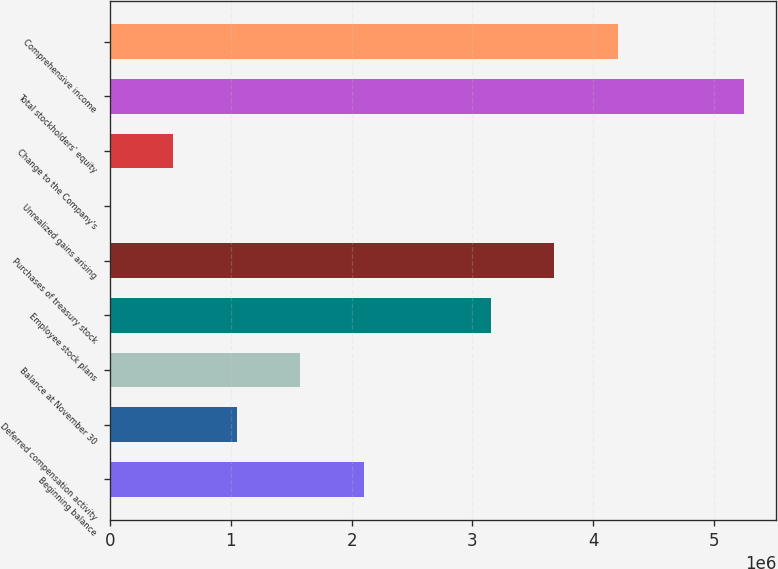Convert chart. <chart><loc_0><loc_0><loc_500><loc_500><bar_chart><fcel>Beginning balance<fcel>Deferred compensation activity<fcel>Balance at November 30<fcel>Employee stock plans<fcel>Purchases of treasury stock<fcel>Unrealized gains arising<fcel>Change to the Company's<fcel>Total stockholders' equity<fcel>Comprehensive income<nl><fcel>2.10068e+06<fcel>1.05043e+06<fcel>1.57555e+06<fcel>3.15092e+06<fcel>3.67604e+06<fcel>185<fcel>525308<fcel>5.25141e+06<fcel>4.20117e+06<nl></chart> 